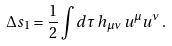<formula> <loc_0><loc_0><loc_500><loc_500>\Delta s _ { 1 } = \frac { 1 } { 2 } \int d \tau \, h _ { \mu \nu } \, u ^ { \mu } u ^ { \nu } \, .</formula> 